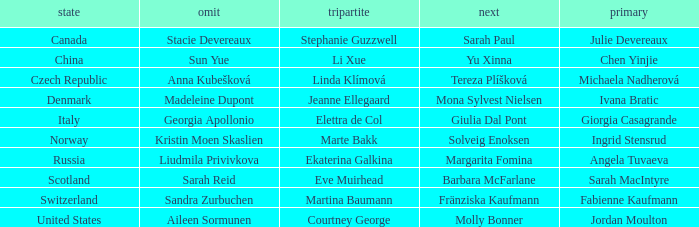What skip has angela tuvaeva as the lead? Liudmila Privivkova. 